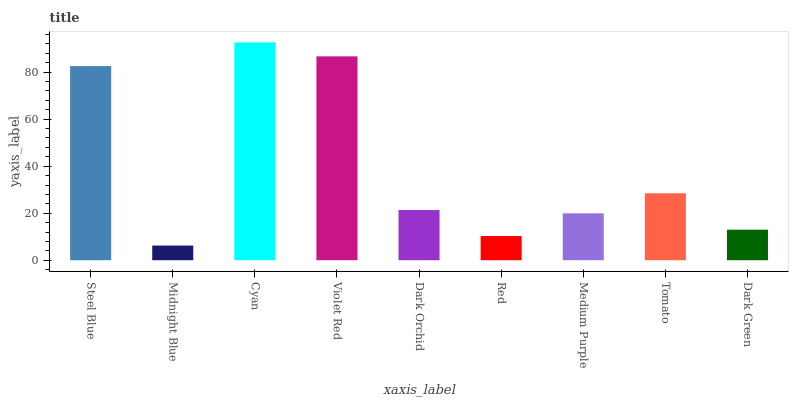Is Midnight Blue the minimum?
Answer yes or no. Yes. Is Cyan the maximum?
Answer yes or no. Yes. Is Cyan the minimum?
Answer yes or no. No. Is Midnight Blue the maximum?
Answer yes or no. No. Is Cyan greater than Midnight Blue?
Answer yes or no. Yes. Is Midnight Blue less than Cyan?
Answer yes or no. Yes. Is Midnight Blue greater than Cyan?
Answer yes or no. No. Is Cyan less than Midnight Blue?
Answer yes or no. No. Is Dark Orchid the high median?
Answer yes or no. Yes. Is Dark Orchid the low median?
Answer yes or no. Yes. Is Midnight Blue the high median?
Answer yes or no. No. Is Violet Red the low median?
Answer yes or no. No. 